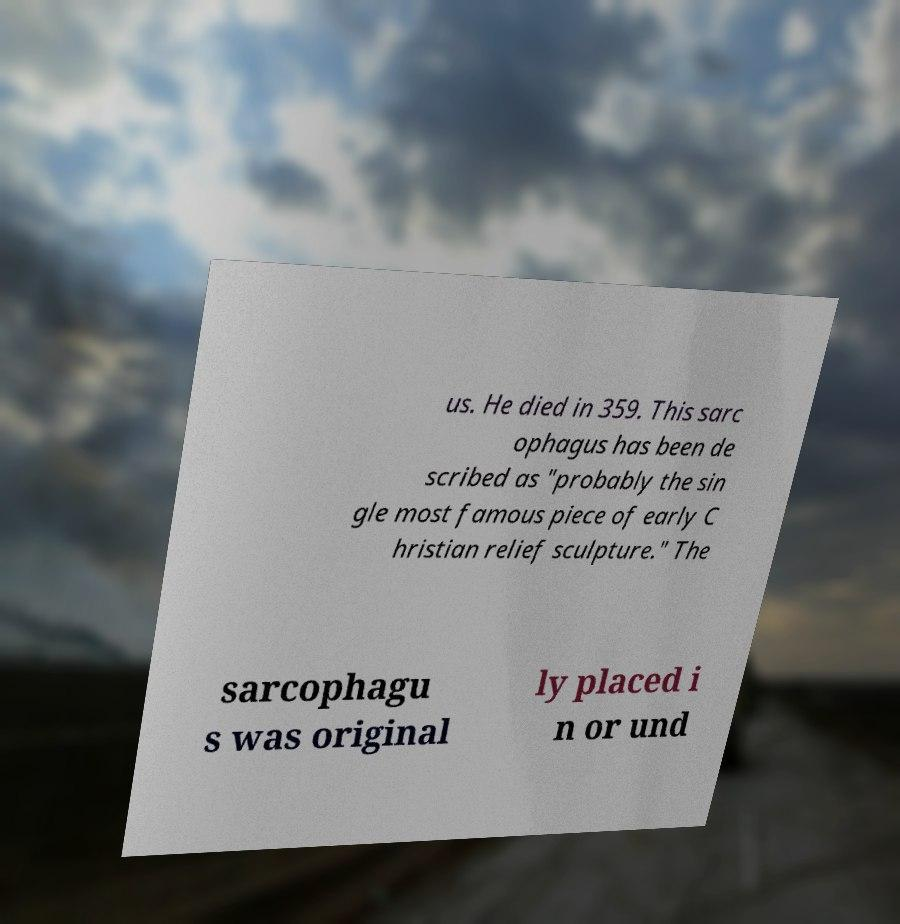I need the written content from this picture converted into text. Can you do that? us. He died in 359. This sarc ophagus has been de scribed as "probably the sin gle most famous piece of early C hristian relief sculpture." The sarcophagu s was original ly placed i n or und 